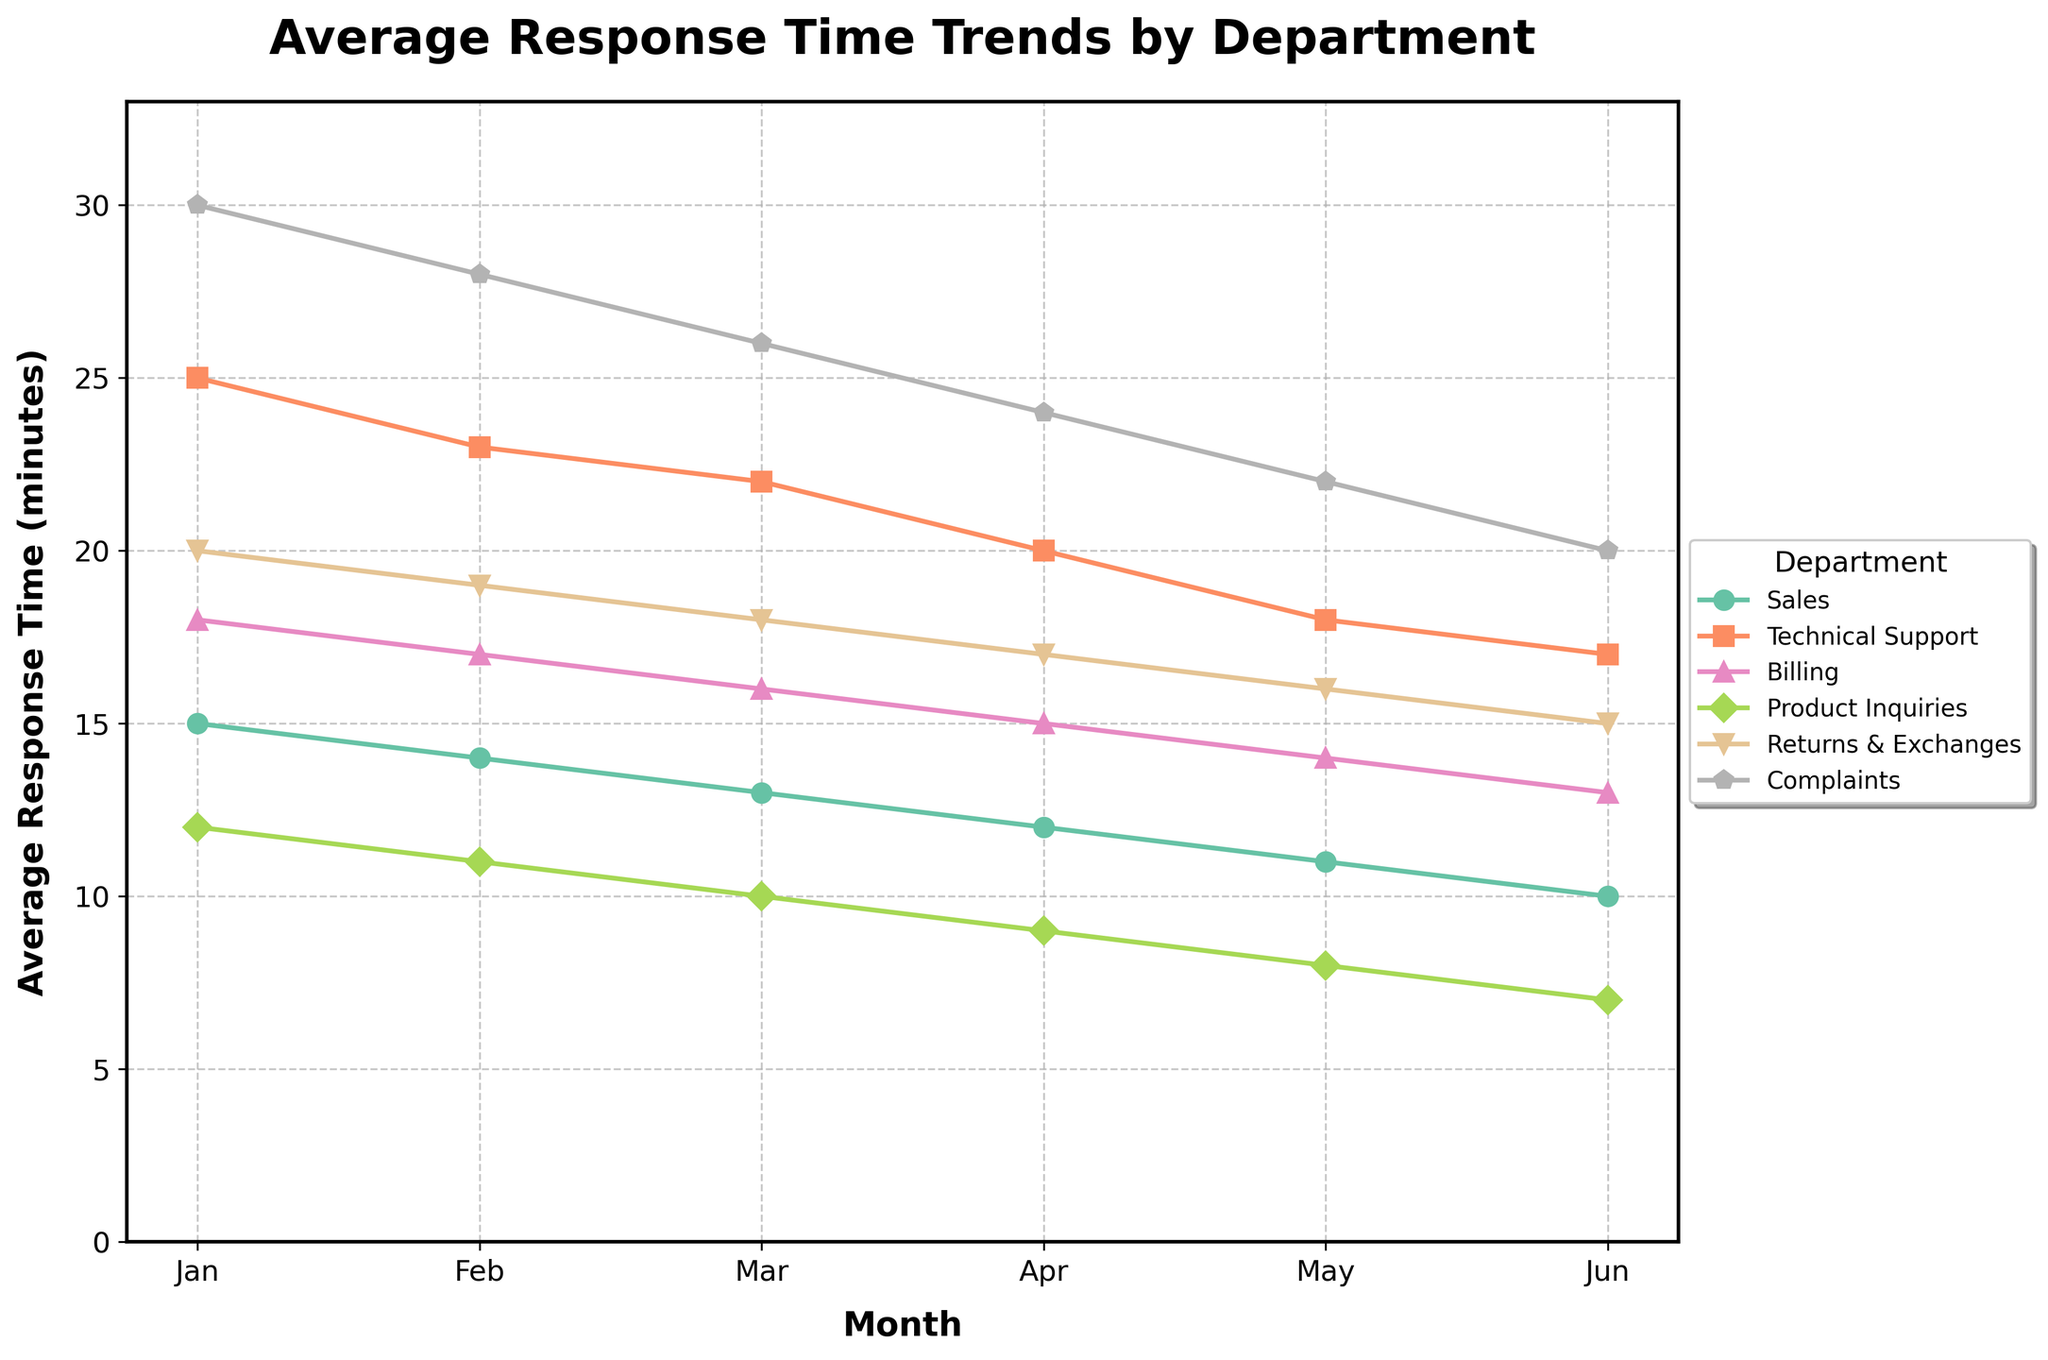What's the trend of the average response time for Complaints? Observing the Complaints line, it starts at 30 minutes in January and steadily declines to 20 minutes by June. This indicates a consistent decrease in the average response time over the months.
Answer: A consistent decrease Which department had the highest response time in February, and what was it? Looking at the plot, the line for Complaints in February is the highest among all departments, with a response time of 28 minutes.
Answer: Complaints, 28 minutes Which two departments have the closest response times in May, and what are the values? The lines for Billing and Returns & Exchanges in May are very close to each other, both registering around 14 and 16 minutes respectively.
Answer: Billing: 14, Returns & Exchanges: 16 What's the combined response time for Sales and Technical Support in April? From the figure, Sales had an average response time of 12 minutes in April, while Technical Support had 20 minutes. The combined time is 12 + 20 = 32 minutes.
Answer: 32 minutes Is the trend of average response time for Product Inquiries different from Technical Support? Yes, Product Inquiries shows a consistently declining trend from 12 to 7 minutes, whereas Technical Support also declines but starts from a higher initial point of 25 to 17 minutes.
Answer: Yes, both decline but start from different points Which department improved its response time the most from January to June? By comparing the starting and ending points for each department, Complaint's line shows the largest decrease from 30 to 20 minutes, indicating the most improvement.
Answer: Complaints Which month has the largest spread of response times across departments? February shows the largest spread as Complaints is at 28 minutes and Product Inquiries is at 11 minutes, indicating a large range. Calculate: 28 - 11 = 17.
Answer: February Which department consistently maintained the lowest average response time throughout the period? Observing the figure, Product Inquiries consistently has the lowest average response time among all departments in every month.
Answer: Product Inquiries What can be inferred about the response time trends for Returns & Exchanges and Billing? Both departments show a steady decline in average response time over the six months with Returns & Exchanges decreasing from 20 to 15 minutes and Billing from 18 to 13 minutes.
Answer: Both show steady decline What is the average response time for Sales over the six months? Look at the values for Sales: (15 + 14 + 13 + 12 + 11 + 10) = 75. Calculate the average: 75 / 6 = 12.5 minutes.
Answer: 12.5 minutes 